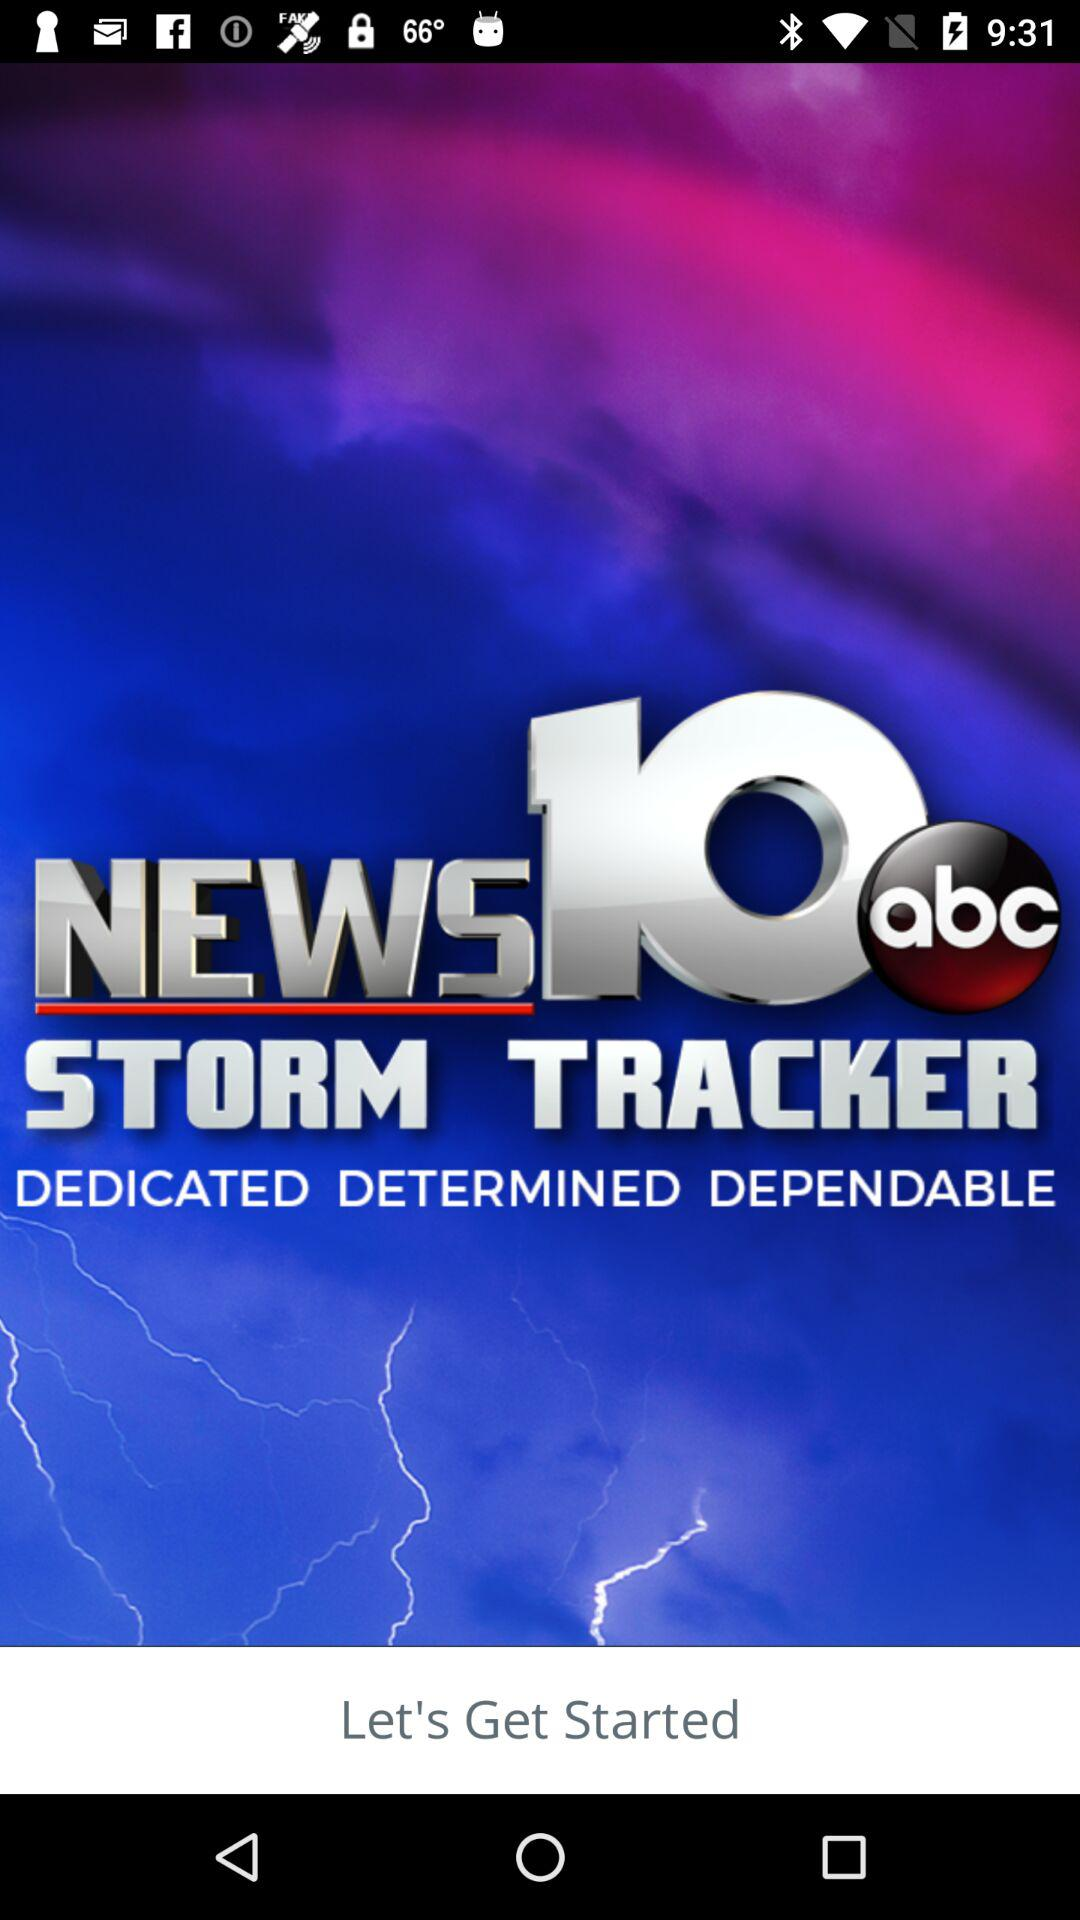When will the next storm come in?
When the provided information is insufficient, respond with <no answer>. <no answer> 